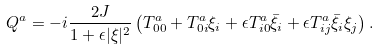<formula> <loc_0><loc_0><loc_500><loc_500>Q ^ { a } = - i \frac { 2 J } { 1 + \epsilon | \xi | ^ { 2 } } \left ( T _ { 0 0 } ^ { a } + T _ { 0 i } ^ { a } \xi _ { i } + \epsilon T _ { i 0 } ^ { a } \bar { \xi } _ { i } + \epsilon T _ { i j } ^ { a } \bar { \xi } _ { i } \xi _ { j } \right ) .</formula> 